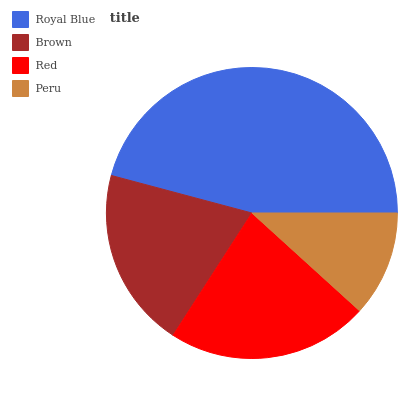Is Peru the minimum?
Answer yes or no. Yes. Is Royal Blue the maximum?
Answer yes or no. Yes. Is Brown the minimum?
Answer yes or no. No. Is Brown the maximum?
Answer yes or no. No. Is Royal Blue greater than Brown?
Answer yes or no. Yes. Is Brown less than Royal Blue?
Answer yes or no. Yes. Is Brown greater than Royal Blue?
Answer yes or no. No. Is Royal Blue less than Brown?
Answer yes or no. No. Is Red the high median?
Answer yes or no. Yes. Is Brown the low median?
Answer yes or no. Yes. Is Peru the high median?
Answer yes or no. No. Is Red the low median?
Answer yes or no. No. 